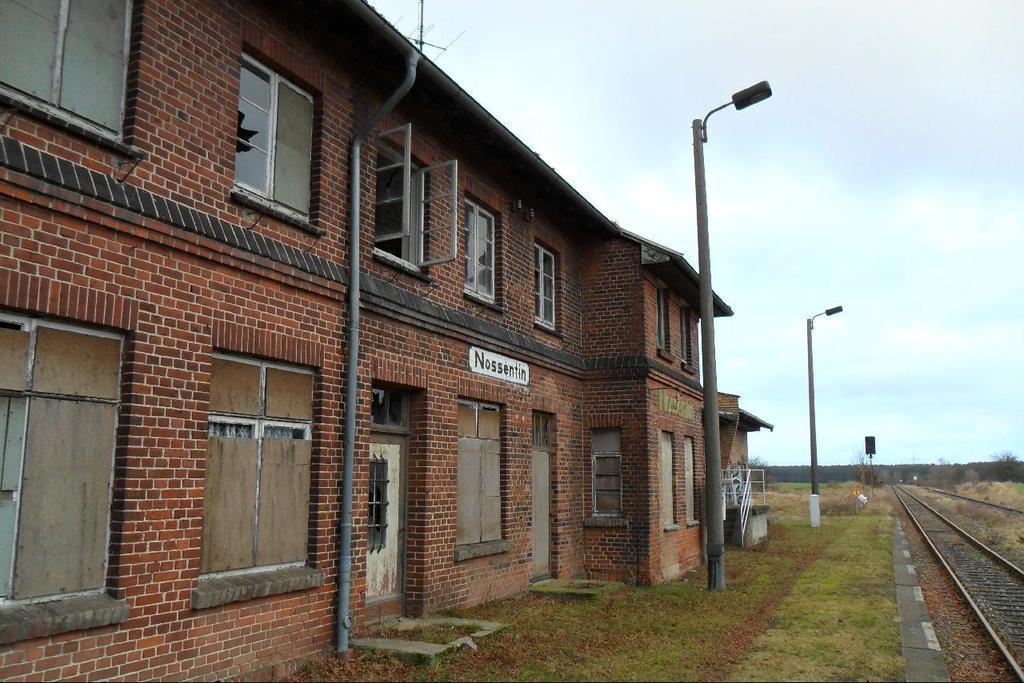Can you describe this image briefly? In this image on the left side there are some buildings, poles and street lights, at the bottom there is a grass and railway track. In the background there are some trees and poles, and on the top of the image there is sky. 